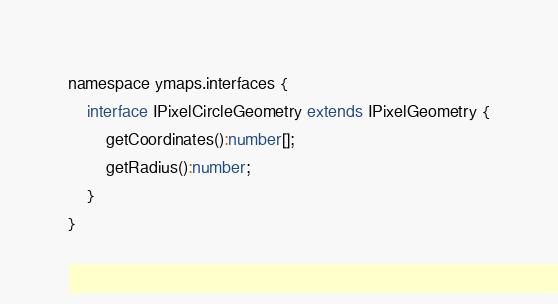Convert code to text. <code><loc_0><loc_0><loc_500><loc_500><_TypeScript_>namespace ymaps.interfaces {
    interface IPixelCircleGeometry extends IPixelGeometry {
        getCoordinates():number[];
        getRadius():number;
    }
}</code> 